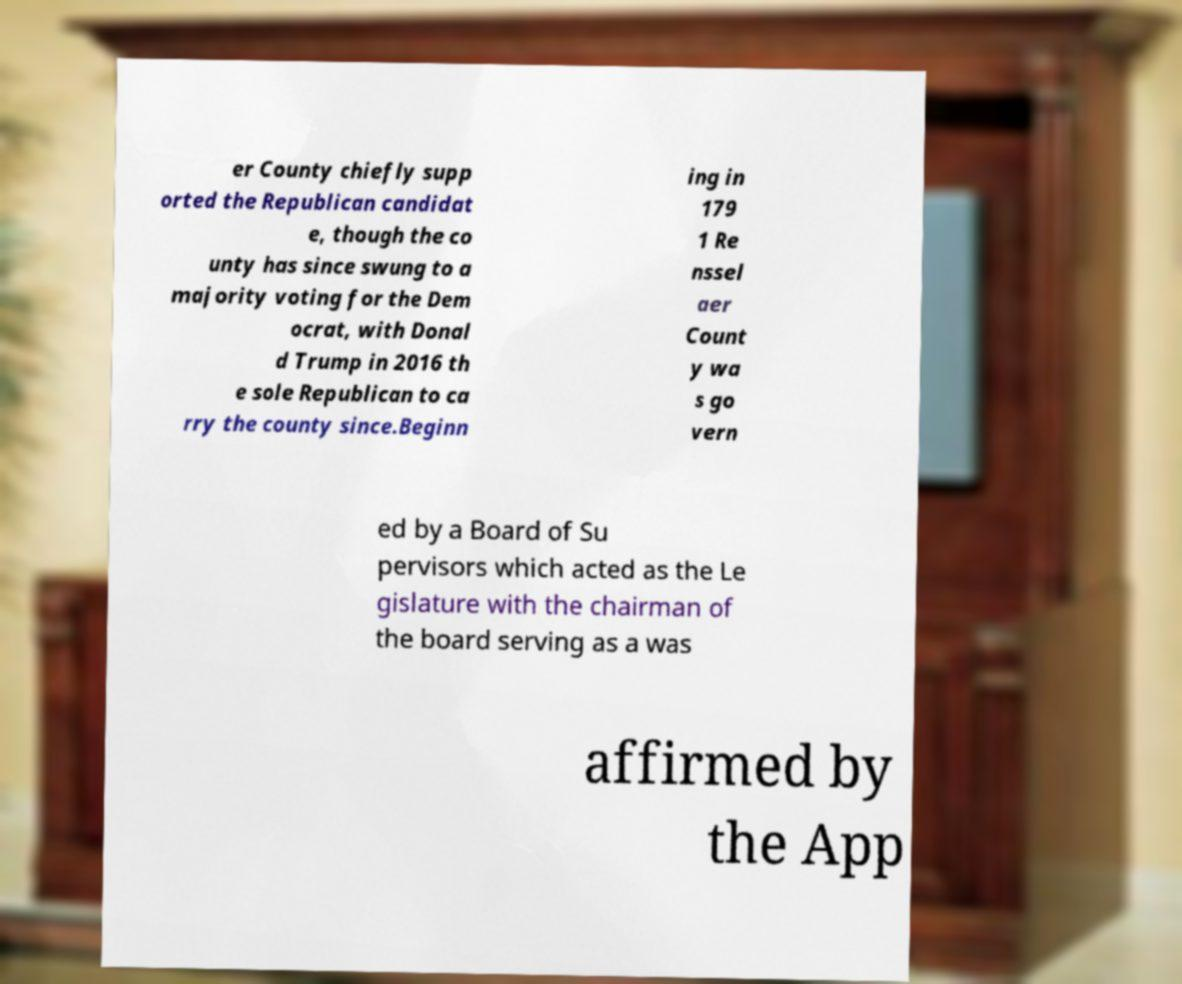Can you read and provide the text displayed in the image?This photo seems to have some interesting text. Can you extract and type it out for me? er County chiefly supp orted the Republican candidat e, though the co unty has since swung to a majority voting for the Dem ocrat, with Donal d Trump in 2016 th e sole Republican to ca rry the county since.Beginn ing in 179 1 Re nssel aer Count y wa s go vern ed by a Board of Su pervisors which acted as the Le gislature with the chairman of the board serving as a was affirmed by the App 